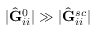<formula> <loc_0><loc_0><loc_500><loc_500>| \hat { G } _ { i i } ^ { 0 } | \gg | \hat { G } _ { i i } ^ { s c } |</formula> 